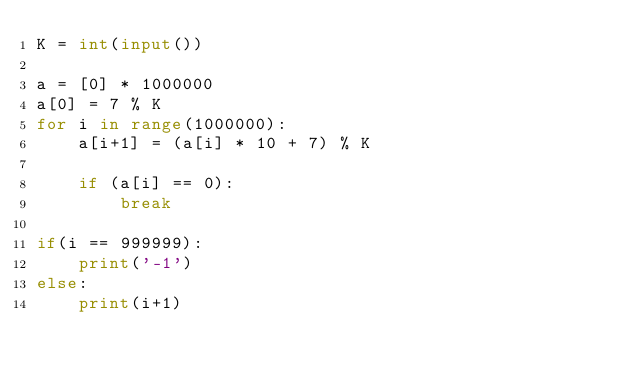Convert code to text. <code><loc_0><loc_0><loc_500><loc_500><_Python_>K = int(input())

a = [0] * 1000000
a[0] = 7 % K
for i in range(1000000):
    a[i+1] = (a[i] * 10 + 7) % K 
    
    if (a[i] == 0):
        break

if(i == 999999):
    print('-1')
else:
    print(i+1)
</code> 